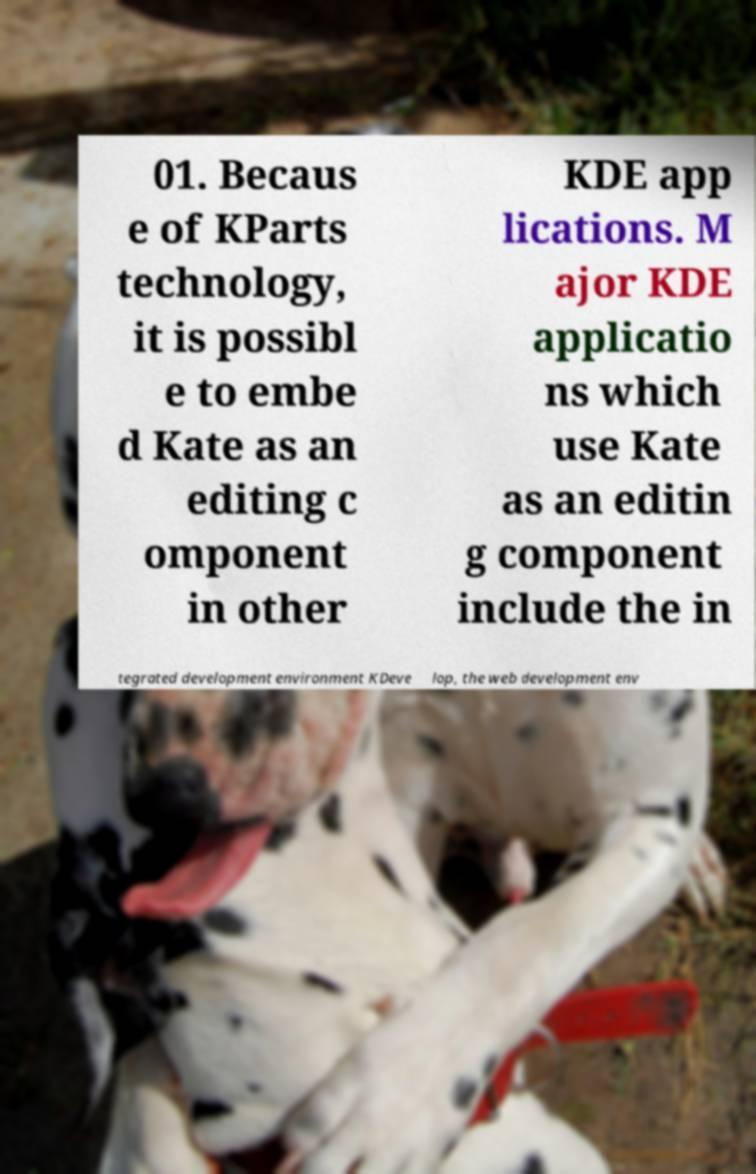What messages or text are displayed in this image? I need them in a readable, typed format. 01. Becaus e of KParts technology, it is possibl e to embe d Kate as an editing c omponent in other KDE app lications. M ajor KDE applicatio ns which use Kate as an editin g component include the in tegrated development environment KDeve lop, the web development env 